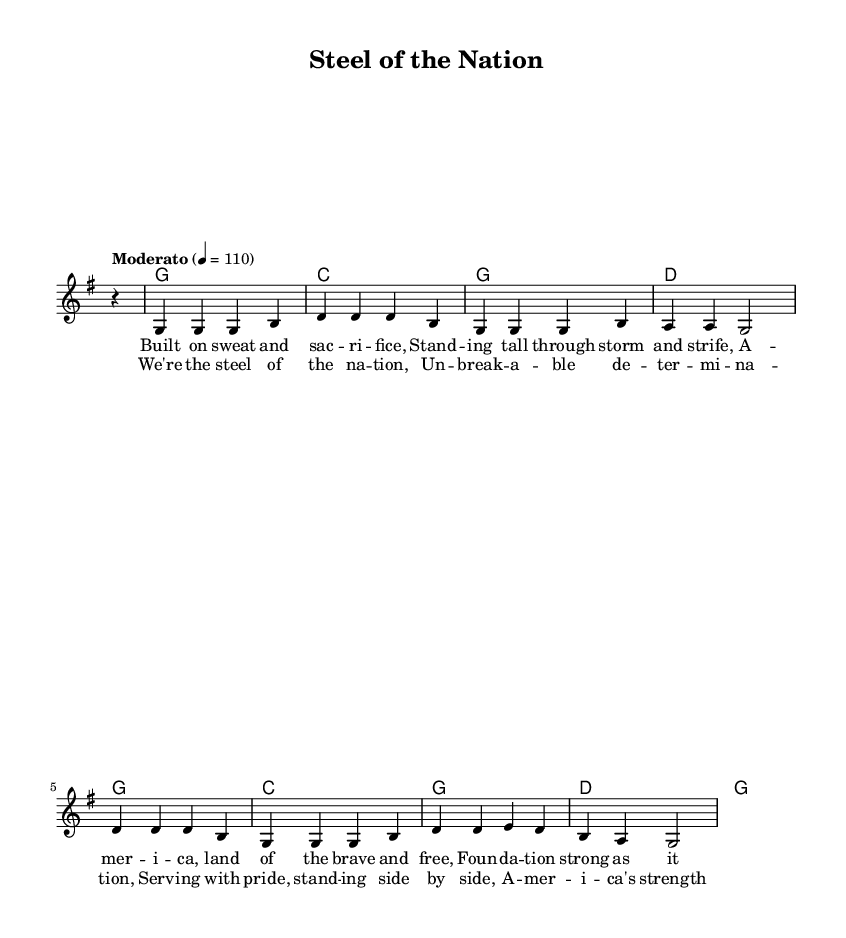What is the key signature of this music? The key signature displayed in the music indicates one sharp, which corresponds to the key of G major.
Answer: G major What is the time signature of this music? The time signature shown in the music is 4/4, which means there are four beats in each measure and the quarter note gets one beat.
Answer: 4/4 What is the tempo marking of this piece? The tempo marking is “Moderato” with a metronome marking of 110 beats per minute, which suggests a moderate pace for the performance.
Answer: Moderato How many measures are there in the verse? Counting the measures in the verse section reveals that there are four distinct measures.
Answer: 4 What is the last note in the chorus melody? Looking at the melody in the chorus, the last note is a G, which is indicated by the last note in the melody line.
Answer: G What is the emotional theme expressed in the lyrics of this song? The lyrics highlight themes of strength, resilience, and pride in American values, focusing on service and determination.
Answer: Strength What musical form does the song follow, based on the structure seen in the sheet music? The structure includes verses followed by a chorus, indicating a common verse-chorus form that is typical in popular and patriotic songs.
Answer: Verse-Chorus 